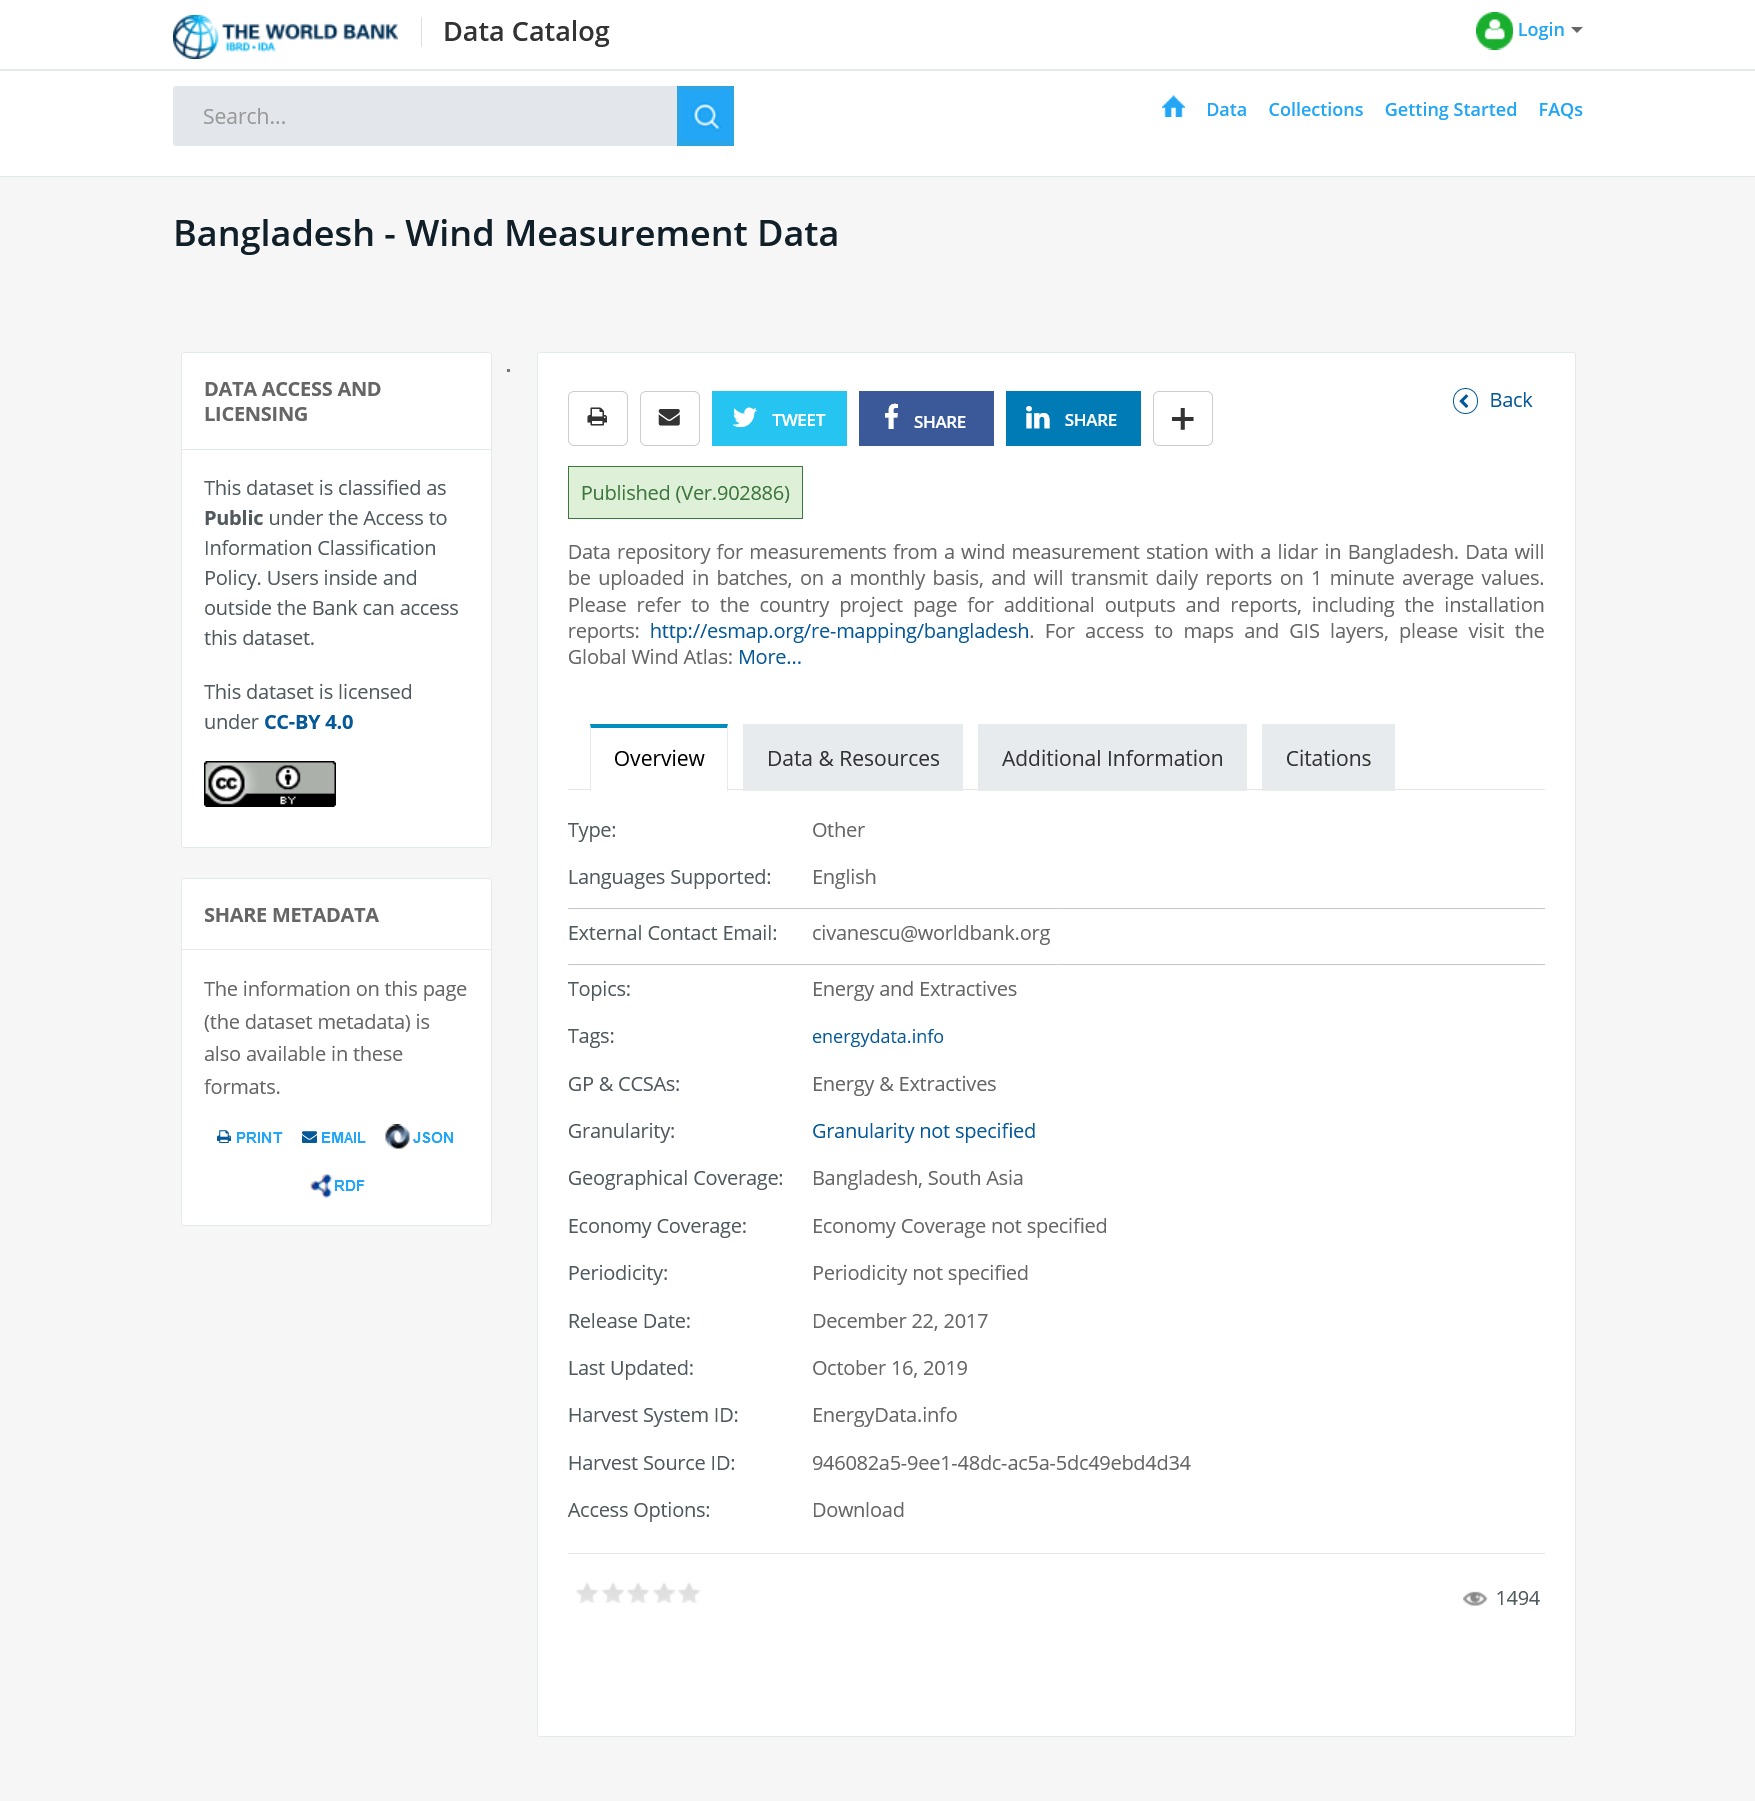Highlight a few significant elements in this photo. The data set is classified as public. The type of measurement system used in wind tunnel testing is known as a hot-wire anemometer. This article is from Bangladesh. 